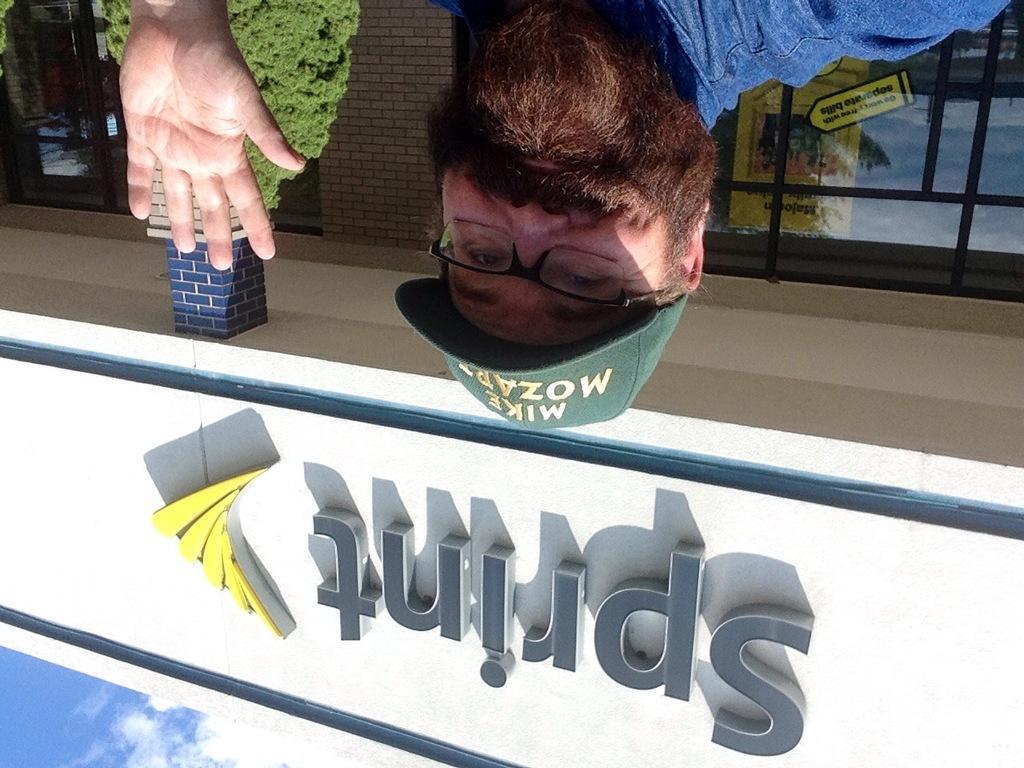How would you summarize this image in a sentence or two? On the top of the image, we can see one person smiling and he is wearing a cap. In the background, we can see the sky, clouds, one building, banner, glass, pillar, tree and a few other objects. 